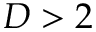Convert formula to latex. <formula><loc_0><loc_0><loc_500><loc_500>D > 2</formula> 